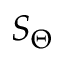Convert formula to latex. <formula><loc_0><loc_0><loc_500><loc_500>S _ { \Theta }</formula> 